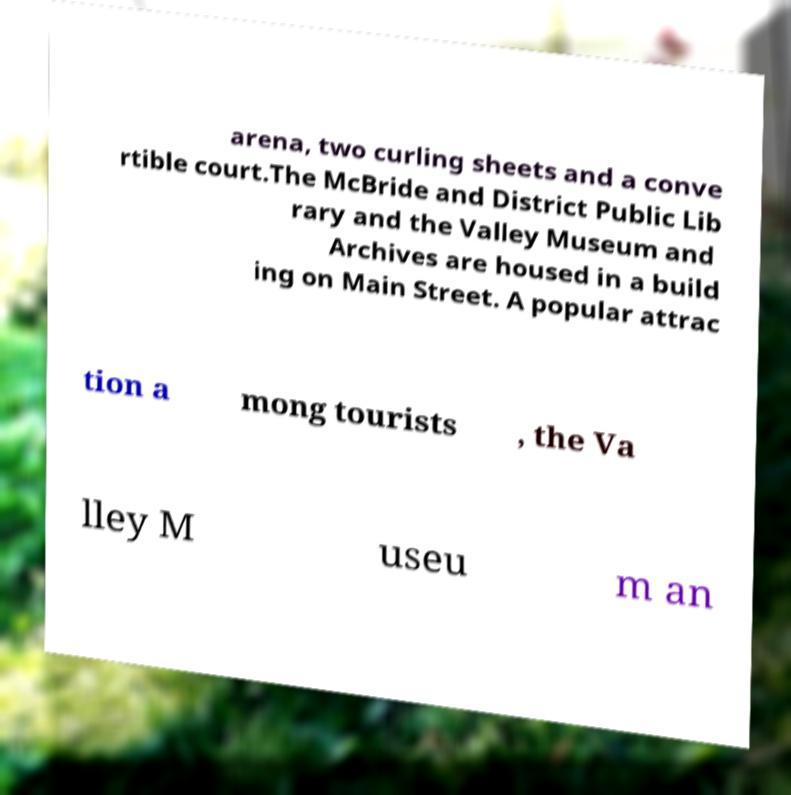Could you extract and type out the text from this image? arena, two curling sheets and a conve rtible court.The McBride and District Public Lib rary and the Valley Museum and Archives are housed in a build ing on Main Street. A popular attrac tion a mong tourists , the Va lley M useu m an 